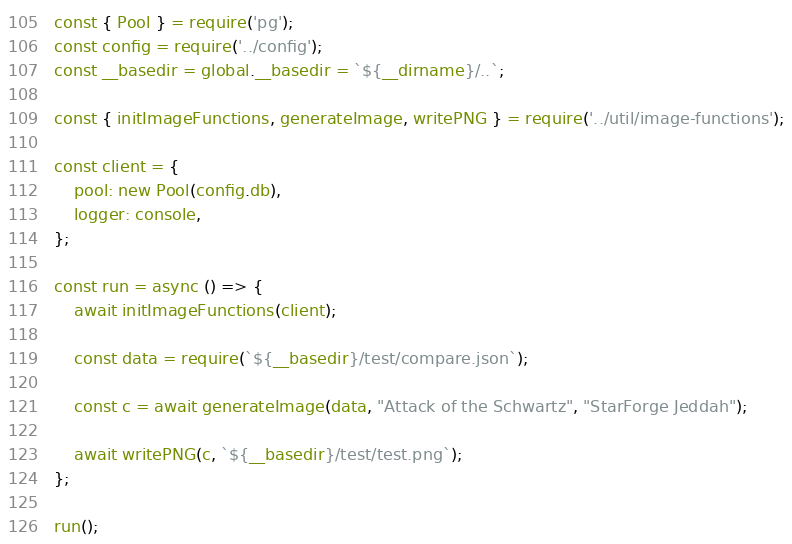<code> <loc_0><loc_0><loc_500><loc_500><_JavaScript_>const { Pool } = require('pg');
const config = require('../config');
const __basedir = global.__basedir = `${__dirname}/..`;

const { initImageFunctions, generateImage, writePNG } = require('../util/image-functions');

const client = {
    pool: new Pool(config.db),
    logger: console,
};

const run = async () => {
    await initImageFunctions(client);

    const data = require(`${__basedir}/test/compare.json`);

    const c = await generateImage(data, "Attack of the Schwartz", "StarForge Jeddah");

    await writePNG(c, `${__basedir}/test/test.png`);
};

run();</code> 